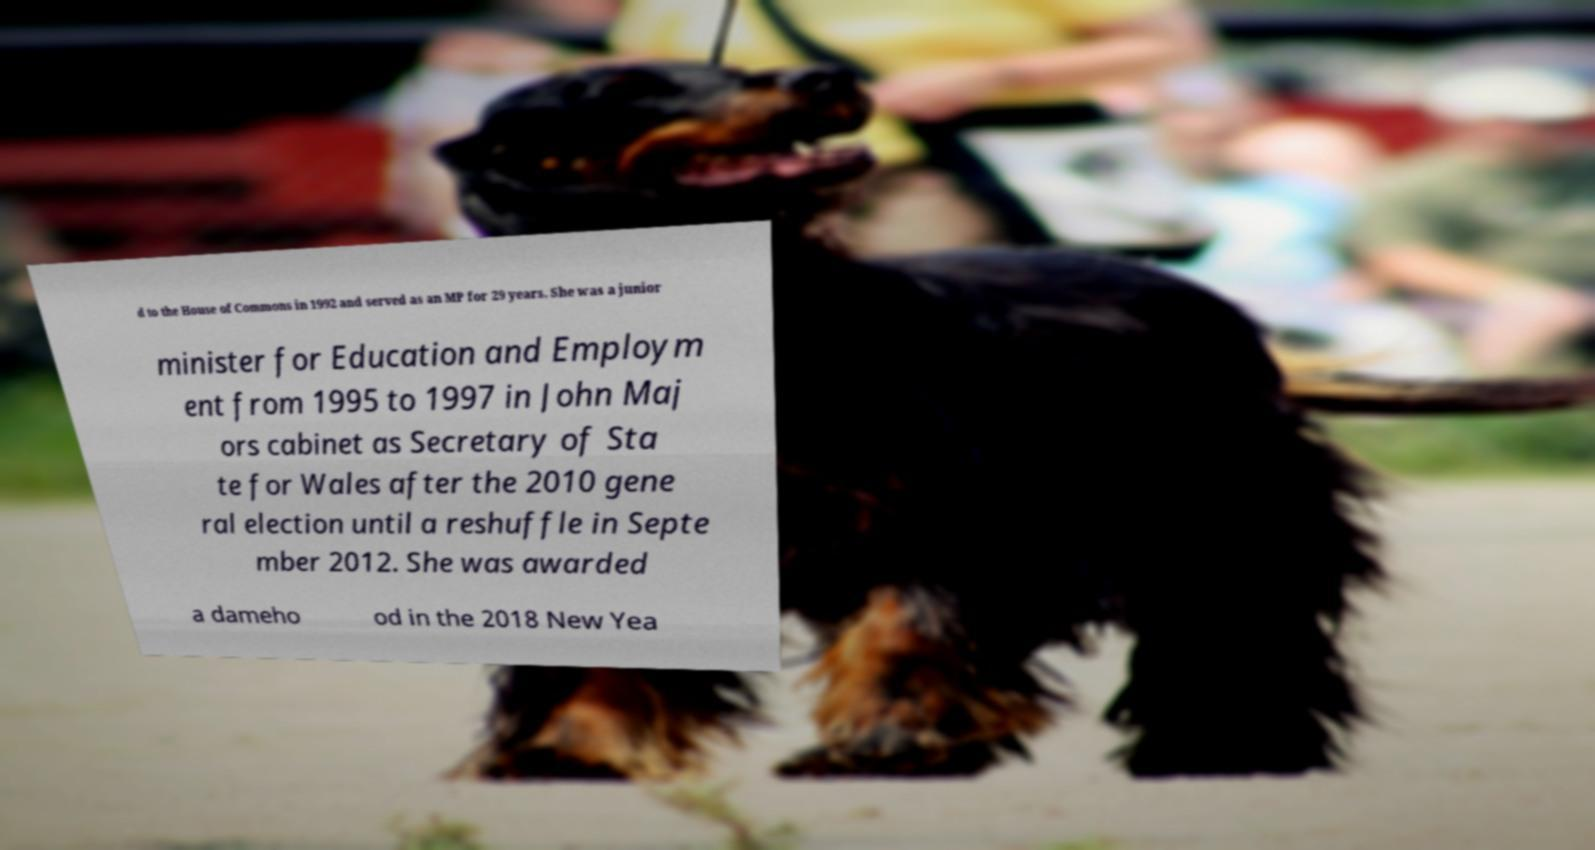Could you extract and type out the text from this image? d to the House of Commons in 1992 and served as an MP for 29 years. She was a junior minister for Education and Employm ent from 1995 to 1997 in John Maj ors cabinet as Secretary of Sta te for Wales after the 2010 gene ral election until a reshuffle in Septe mber 2012. She was awarded a dameho od in the 2018 New Yea 